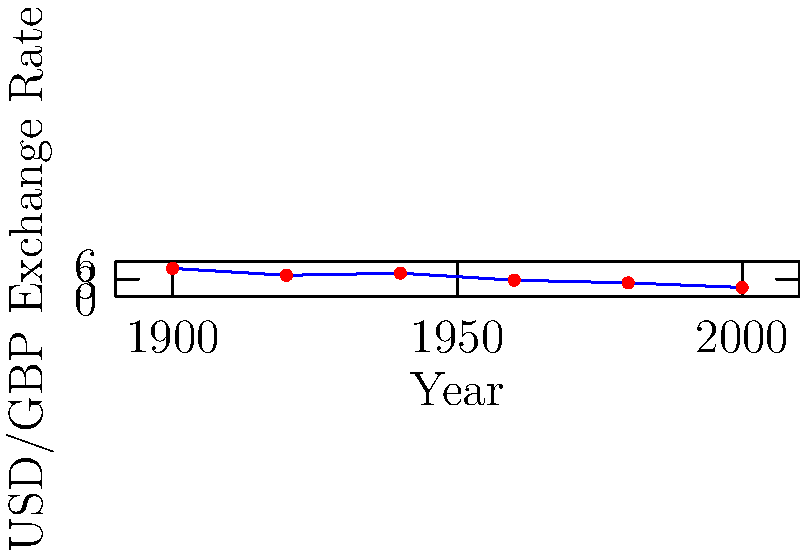The graph shows the historical exchange rates between the US Dollar (USD) and British Pound (GBP) from 1900 to 2000. If we represent each data point as a vector $\mathbf{v}_i = (x_i, y_i)$, where $x_i$ is the year and $y_i$ is the exchange rate, what is the magnitude of the vector representing the change in exchange rate from 1900 to 2000? To solve this problem, we need to follow these steps:

1) Identify the vectors for 1900 and 2000:
   $\mathbf{v}_{1900} = (1900, 4.87)$
   $\mathbf{v}_{2000} = (2000, 1.52)$

2) Calculate the difference vector:
   $\Delta \mathbf{v} = \mathbf{v}_{2000} - \mathbf{v}_{1900} = (2000 - 1900, 1.52 - 4.87) = (100, -3.35)$

3) Calculate the magnitude of the difference vector using the Pythagorean theorem:
   $\|\Delta \mathbf{v}\| = \sqrt{(100)^2 + (-3.35)^2}$

4) Simplify:
   $\|\Delta \mathbf{v}\| = \sqrt{10000 + 11.2225} = \sqrt{10011.2225}$

5) Calculate the final result:
   $\|\Delta \mathbf{v}\| \approx 100.0561$

Therefore, the magnitude of the vector representing the change in exchange rate from 1900 to 2000 is approximately 100.0561.
Answer: $100.0561$ 